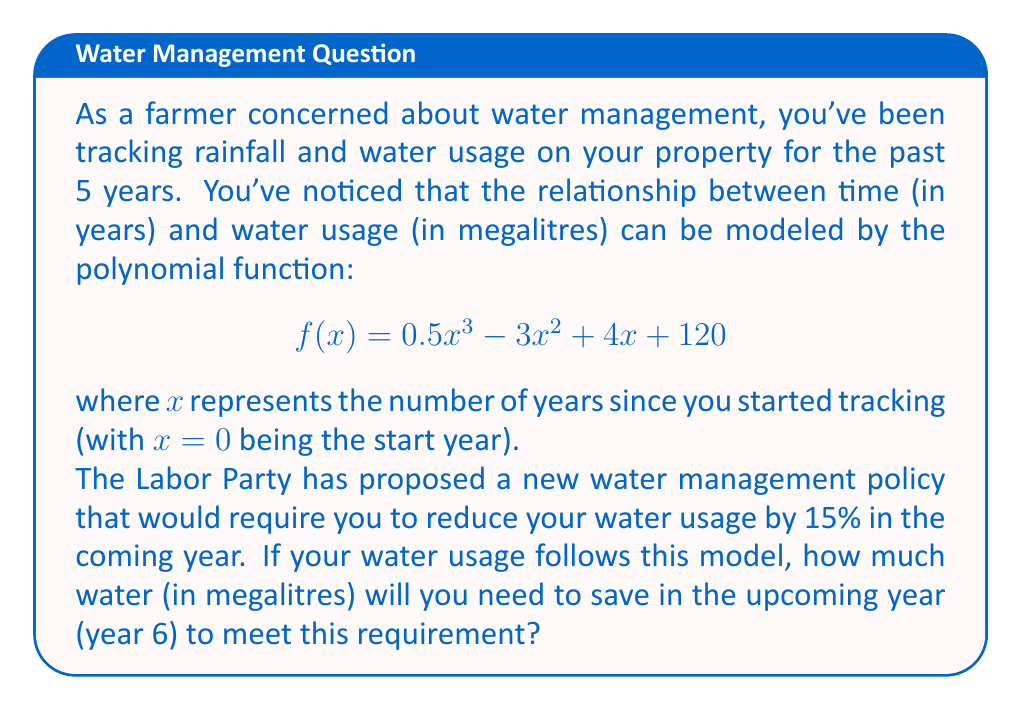Can you solve this math problem? To solve this problem, we need to follow these steps:

1. Calculate the water usage for year 5 (current year):
   $f(5) = 0.5(5)^3 - 3(5)^2 + 4(5) + 120$
   $= 0.5(125) - 3(25) + 20 + 120$
   $= 62.5 - 75 + 20 + 120$
   $= 127.5$ megalitres

2. Calculate the water usage for year 6 (upcoming year):
   $f(6) = 0.5(6)^3 - 3(6)^2 + 4(6) + 120$
   $= 0.5(216) - 3(36) + 24 + 120$
   $= 108 - 108 + 24 + 120$
   $= 144$ megalitres

3. Calculate 85% of the year 6 usage (the new target after 15% reduction):
   $144 \times 0.85 = 122.4$ megalitres

4. Calculate the difference between the projected usage and the new target:
   $144 - 122.4 = 21.6$ megalitres

This difference represents the amount of water that needs to be saved to meet the 15% reduction requirement.
Answer: To meet the Labor Party's proposed 15% water usage reduction, you will need to save 21.6 megalitres of water in the upcoming year (year 6). 